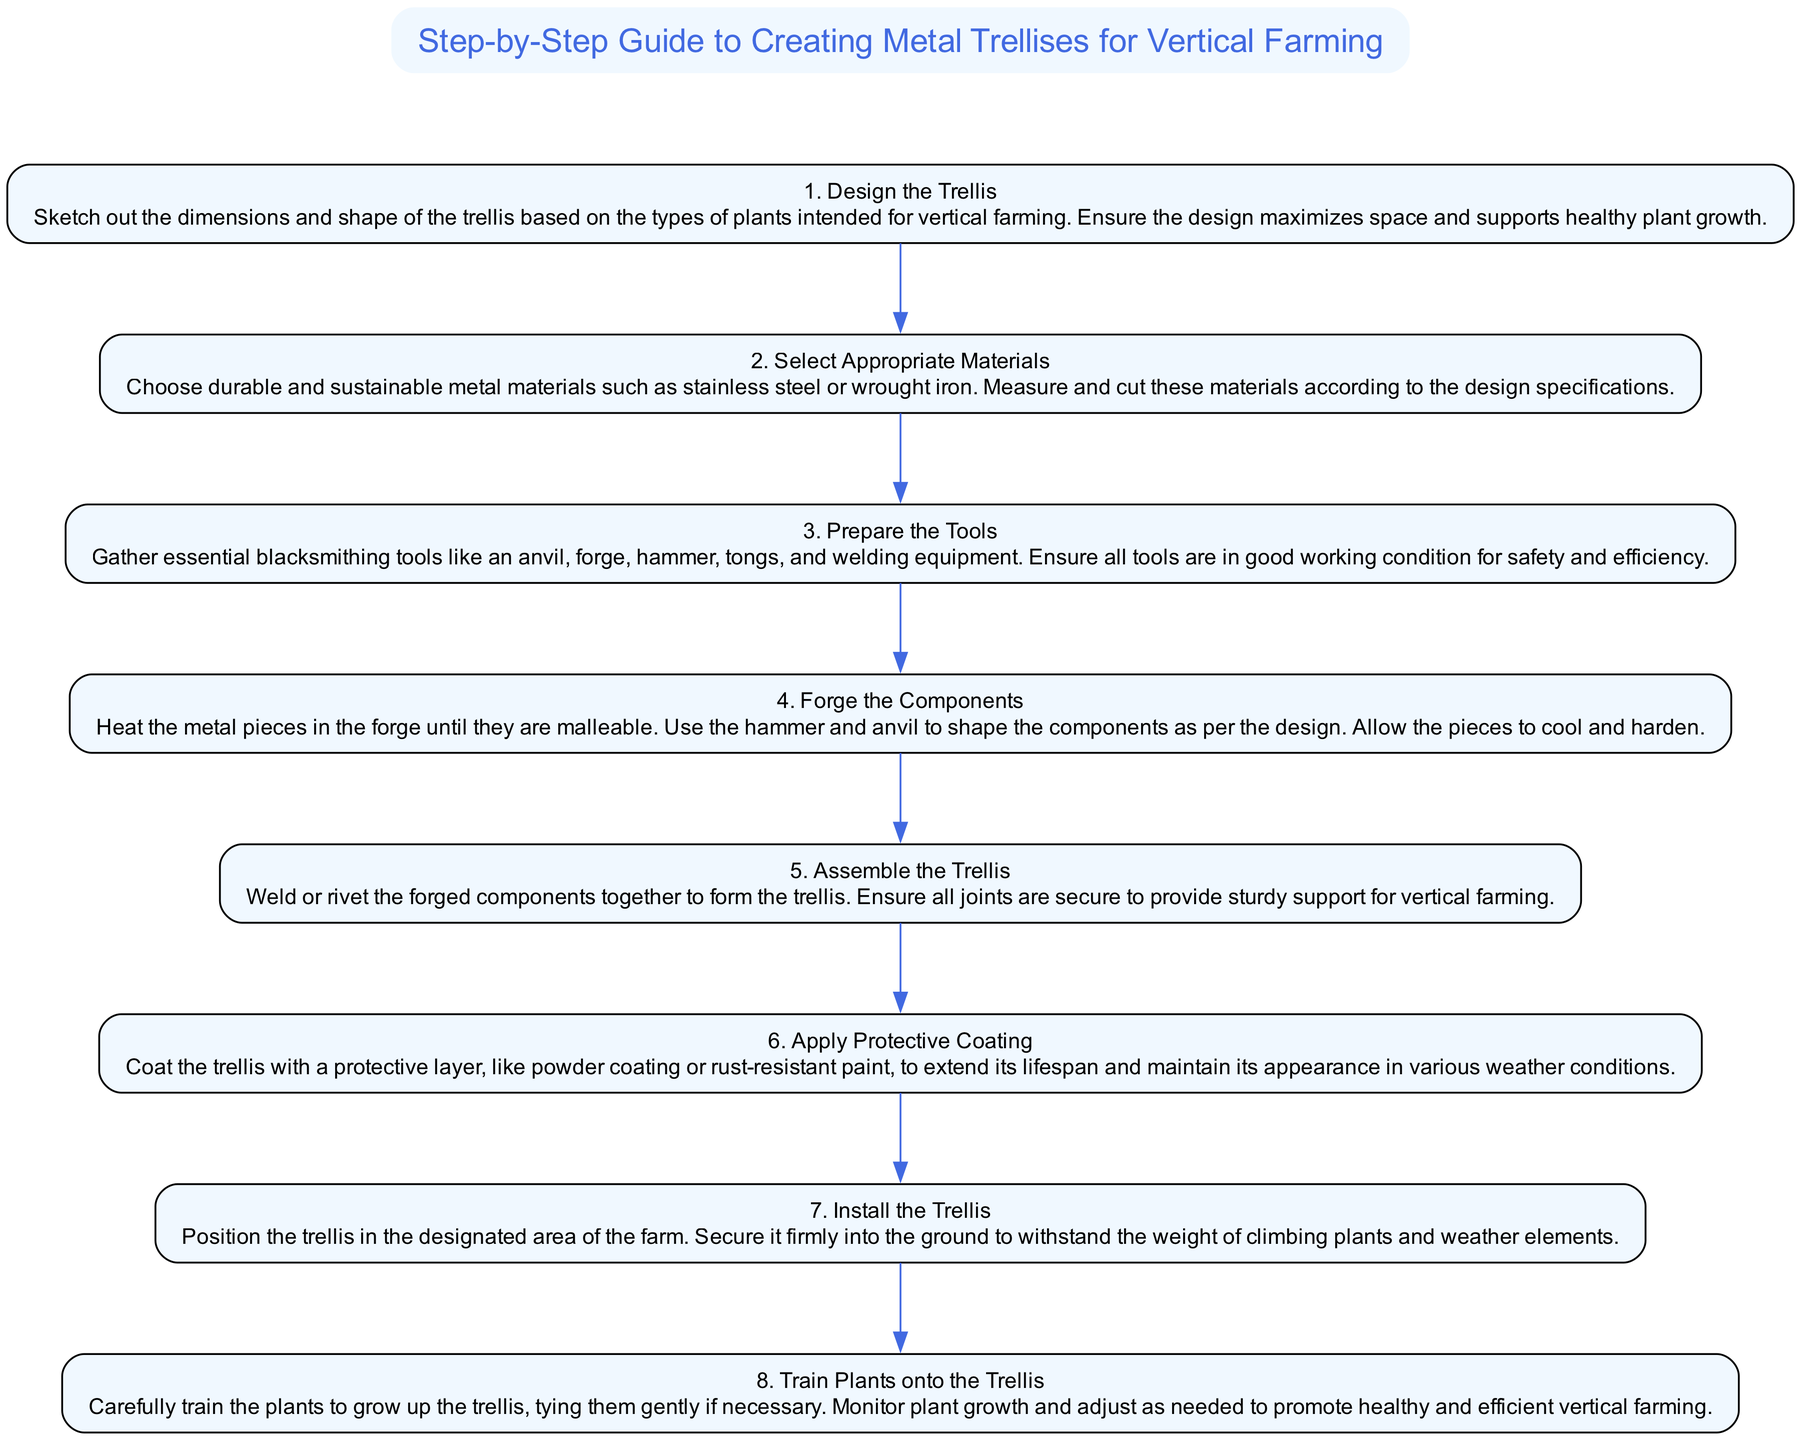What is the first step in creating a metal trellis? The first step is explicitly stated in the diagram as "1. Design the Trellis." It is the topmost node that outlines the initial action needed in the trellis creation process.
Answer: Design the Trellis How many total steps are outlined in the diagram? By counting the individual steps listed in the diagram, there are eight distinct steps from the design phase to training the plants onto the trellis, which can be visibly seen as nodes in the flow chart.
Answer: 8 What materials should be selected for the trellis? The description for Step 2 explicitly mentions "durable and sustainable metal materials such as stainless steel or wrought iron" as the materials to be chosen for the trellis, which is a key piece of information directly displayed in the diagram.
Answer: Stainless steel or wrought iron What follows after forging the components? According to the flow chart, after Step 4 (Forge the Components), the next indicated step is Step 5, which is "Assemble the Trellis." This connection shows the progression required in the creation process, leading from one action to the next.
Answer: Assemble the Trellis Which step involves applying a protective layer? The diagram directly states in Step 6 "Apply Protective Coating," which describes the action of adding a protective layer to the trellis. This is a clear instruction that appears distinctly in the flow of the process.
Answer: Apply Protective Coating What is the relationship between Step 3 and Step 4? In the flow diagram, Step 3 (Prepare the Tools) precedes Step 4 (Forge the Components). This sequential relationship indicates that preparing the tools is a prerequisite for the forging process, as proper tools are necessary for effective blacksmithing.
Answer: Step 3 precedes Step 4 How is the trellis secured in the designated area? Step 7 (Install the Trellis) details that the trellis should be "secured firmly into the ground." This explicit instruction relates to the final positioning of the trellis, ensuring its stability in the farming environment.
Answer: Secured firmly into the ground What action is taken during Step 8? The last step in the process, Step 8, indicates the action of "Train Plants onto the Trellis." This step elaborates on how to assist plants in utilizing the trellis for optimal growth, marking an important concluding action in the flow chart.
Answer: Train Plants onto the Trellis 